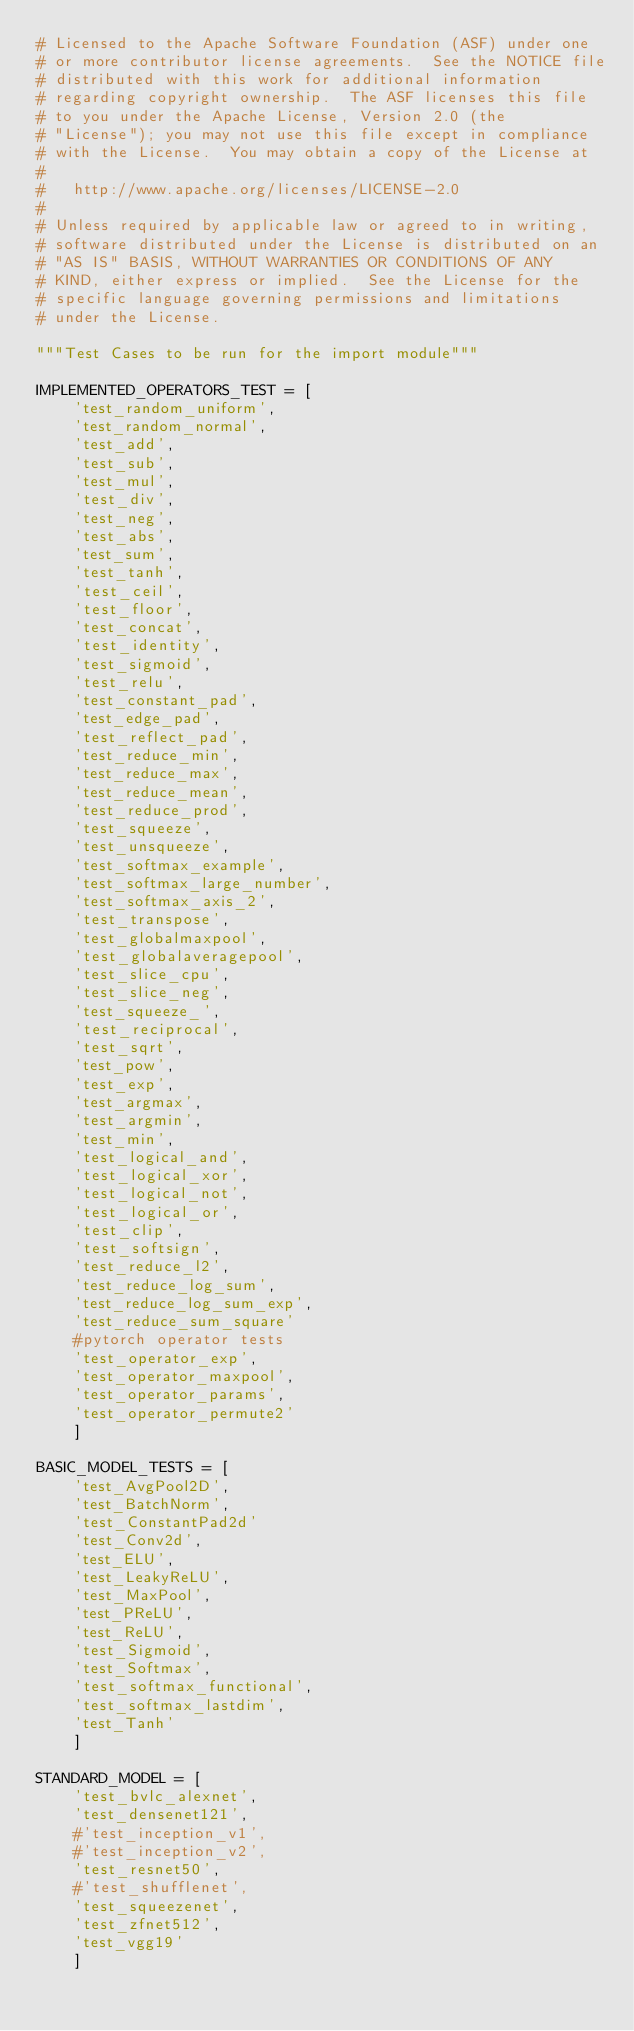<code> <loc_0><loc_0><loc_500><loc_500><_Python_># Licensed to the Apache Software Foundation (ASF) under one
# or more contributor license agreements.  See the NOTICE file
# distributed with this work for additional information
# regarding copyright ownership.  The ASF licenses this file
# to you under the Apache License, Version 2.0 (the
# "License"); you may not use this file except in compliance
# with the License.  You may obtain a copy of the License at
#
#   http://www.apache.org/licenses/LICENSE-2.0
#
# Unless required by applicable law or agreed to in writing,
# software distributed under the License is distributed on an
# "AS IS" BASIS, WITHOUT WARRANTIES OR CONDITIONS OF ANY
# KIND, either express or implied.  See the License for the
# specific language governing permissions and limitations
# under the License.

"""Test Cases to be run for the import module"""

IMPLEMENTED_OPERATORS_TEST = [
    'test_random_uniform',
    'test_random_normal',
    'test_add',
    'test_sub',
    'test_mul',
    'test_div',
    'test_neg',
    'test_abs',
    'test_sum',
    'test_tanh',
    'test_ceil',
    'test_floor',
    'test_concat',
    'test_identity',
    'test_sigmoid',
    'test_relu',
    'test_constant_pad',
    'test_edge_pad',
    'test_reflect_pad',
    'test_reduce_min',
    'test_reduce_max',
    'test_reduce_mean',
    'test_reduce_prod',
    'test_squeeze',
    'test_unsqueeze',
    'test_softmax_example',
    'test_softmax_large_number',
    'test_softmax_axis_2',
    'test_transpose',
    'test_globalmaxpool',
    'test_globalaveragepool',
    'test_slice_cpu',
    'test_slice_neg',
    'test_squeeze_',
    'test_reciprocal',
    'test_sqrt',
    'test_pow',
    'test_exp',
    'test_argmax',
    'test_argmin',
    'test_min',
    'test_logical_and',
    'test_logical_xor',
    'test_logical_not',
    'test_logical_or',
    'test_clip',
    'test_softsign',
    'test_reduce_l2',
    'test_reduce_log_sum',
    'test_reduce_log_sum_exp',
    'test_reduce_sum_square'
    #pytorch operator tests
    'test_operator_exp',
    'test_operator_maxpool',
    'test_operator_params',
    'test_operator_permute2'
    ]

BASIC_MODEL_TESTS = [
    'test_AvgPool2D',
    'test_BatchNorm',
    'test_ConstantPad2d'
    'test_Conv2d',
    'test_ELU',
    'test_LeakyReLU',
    'test_MaxPool',
    'test_PReLU',
    'test_ReLU',
    'test_Sigmoid',
    'test_Softmax',
    'test_softmax_functional',
    'test_softmax_lastdim',
    'test_Tanh'
    ]

STANDARD_MODEL = [
    'test_bvlc_alexnet',
    'test_densenet121',
    #'test_inception_v1',
    #'test_inception_v2',
    'test_resnet50',
    #'test_shufflenet',
    'test_squeezenet',
    'test_zfnet512',
    'test_vgg19'
    ]
</code> 